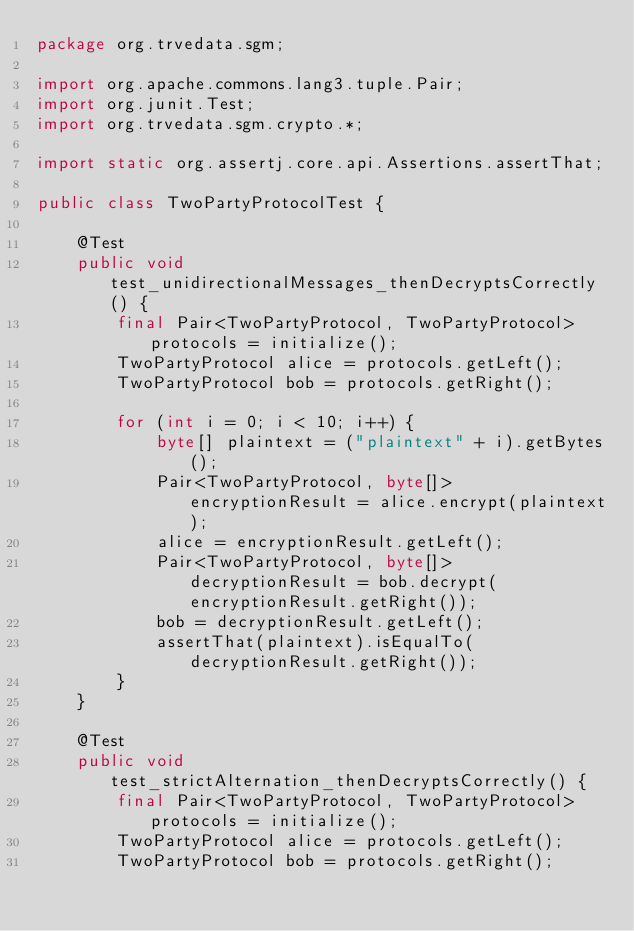<code> <loc_0><loc_0><loc_500><loc_500><_Java_>package org.trvedata.sgm;

import org.apache.commons.lang3.tuple.Pair;
import org.junit.Test;
import org.trvedata.sgm.crypto.*;

import static org.assertj.core.api.Assertions.assertThat;

public class TwoPartyProtocolTest {

    @Test
    public void test_unidirectionalMessages_thenDecryptsCorrectly() {
        final Pair<TwoPartyProtocol, TwoPartyProtocol> protocols = initialize();
        TwoPartyProtocol alice = protocols.getLeft();
        TwoPartyProtocol bob = protocols.getRight();

        for (int i = 0; i < 10; i++) {
            byte[] plaintext = ("plaintext" + i).getBytes();
            Pair<TwoPartyProtocol, byte[]> encryptionResult = alice.encrypt(plaintext);
            alice = encryptionResult.getLeft();
            Pair<TwoPartyProtocol, byte[]> decryptionResult = bob.decrypt(encryptionResult.getRight());
            bob = decryptionResult.getLeft();
            assertThat(plaintext).isEqualTo(decryptionResult.getRight());
        }
    }

    @Test
    public void test_strictAlternation_thenDecryptsCorrectly() {
        final Pair<TwoPartyProtocol, TwoPartyProtocol> protocols = initialize();
        TwoPartyProtocol alice = protocols.getLeft();
        TwoPartyProtocol bob = protocols.getRight();
</code> 